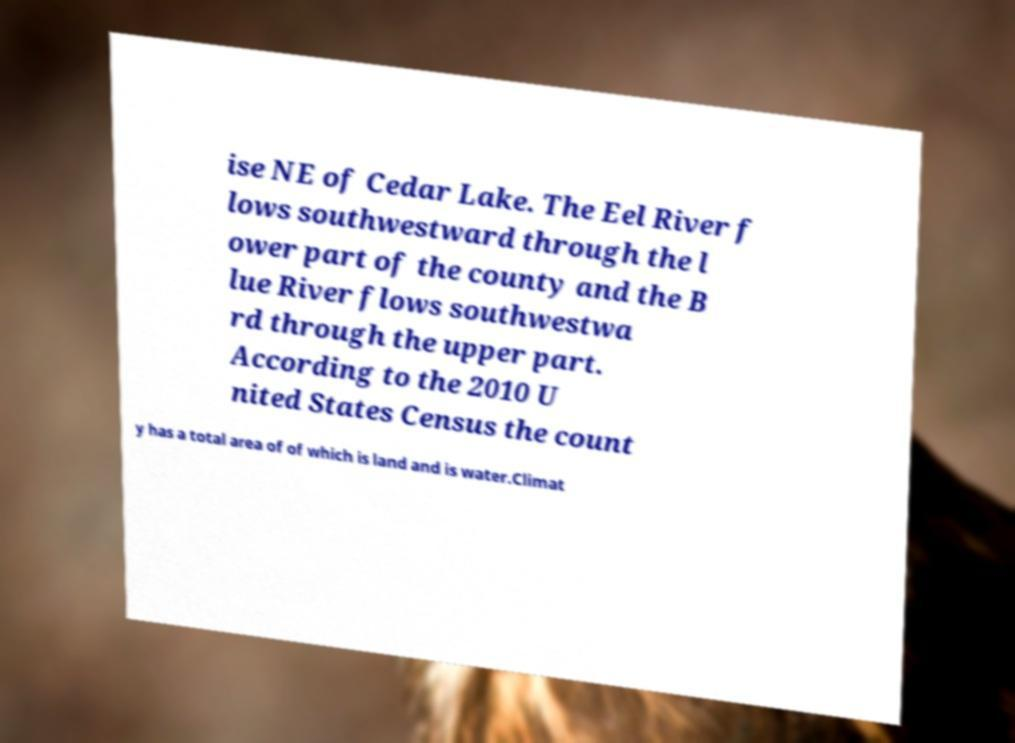Please identify and transcribe the text found in this image. ise NE of Cedar Lake. The Eel River f lows southwestward through the l ower part of the county and the B lue River flows southwestwa rd through the upper part. According to the 2010 U nited States Census the count y has a total area of of which is land and is water.Climat 